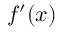<formula> <loc_0><loc_0><loc_500><loc_500>f ^ { \prime } ( x )</formula> 